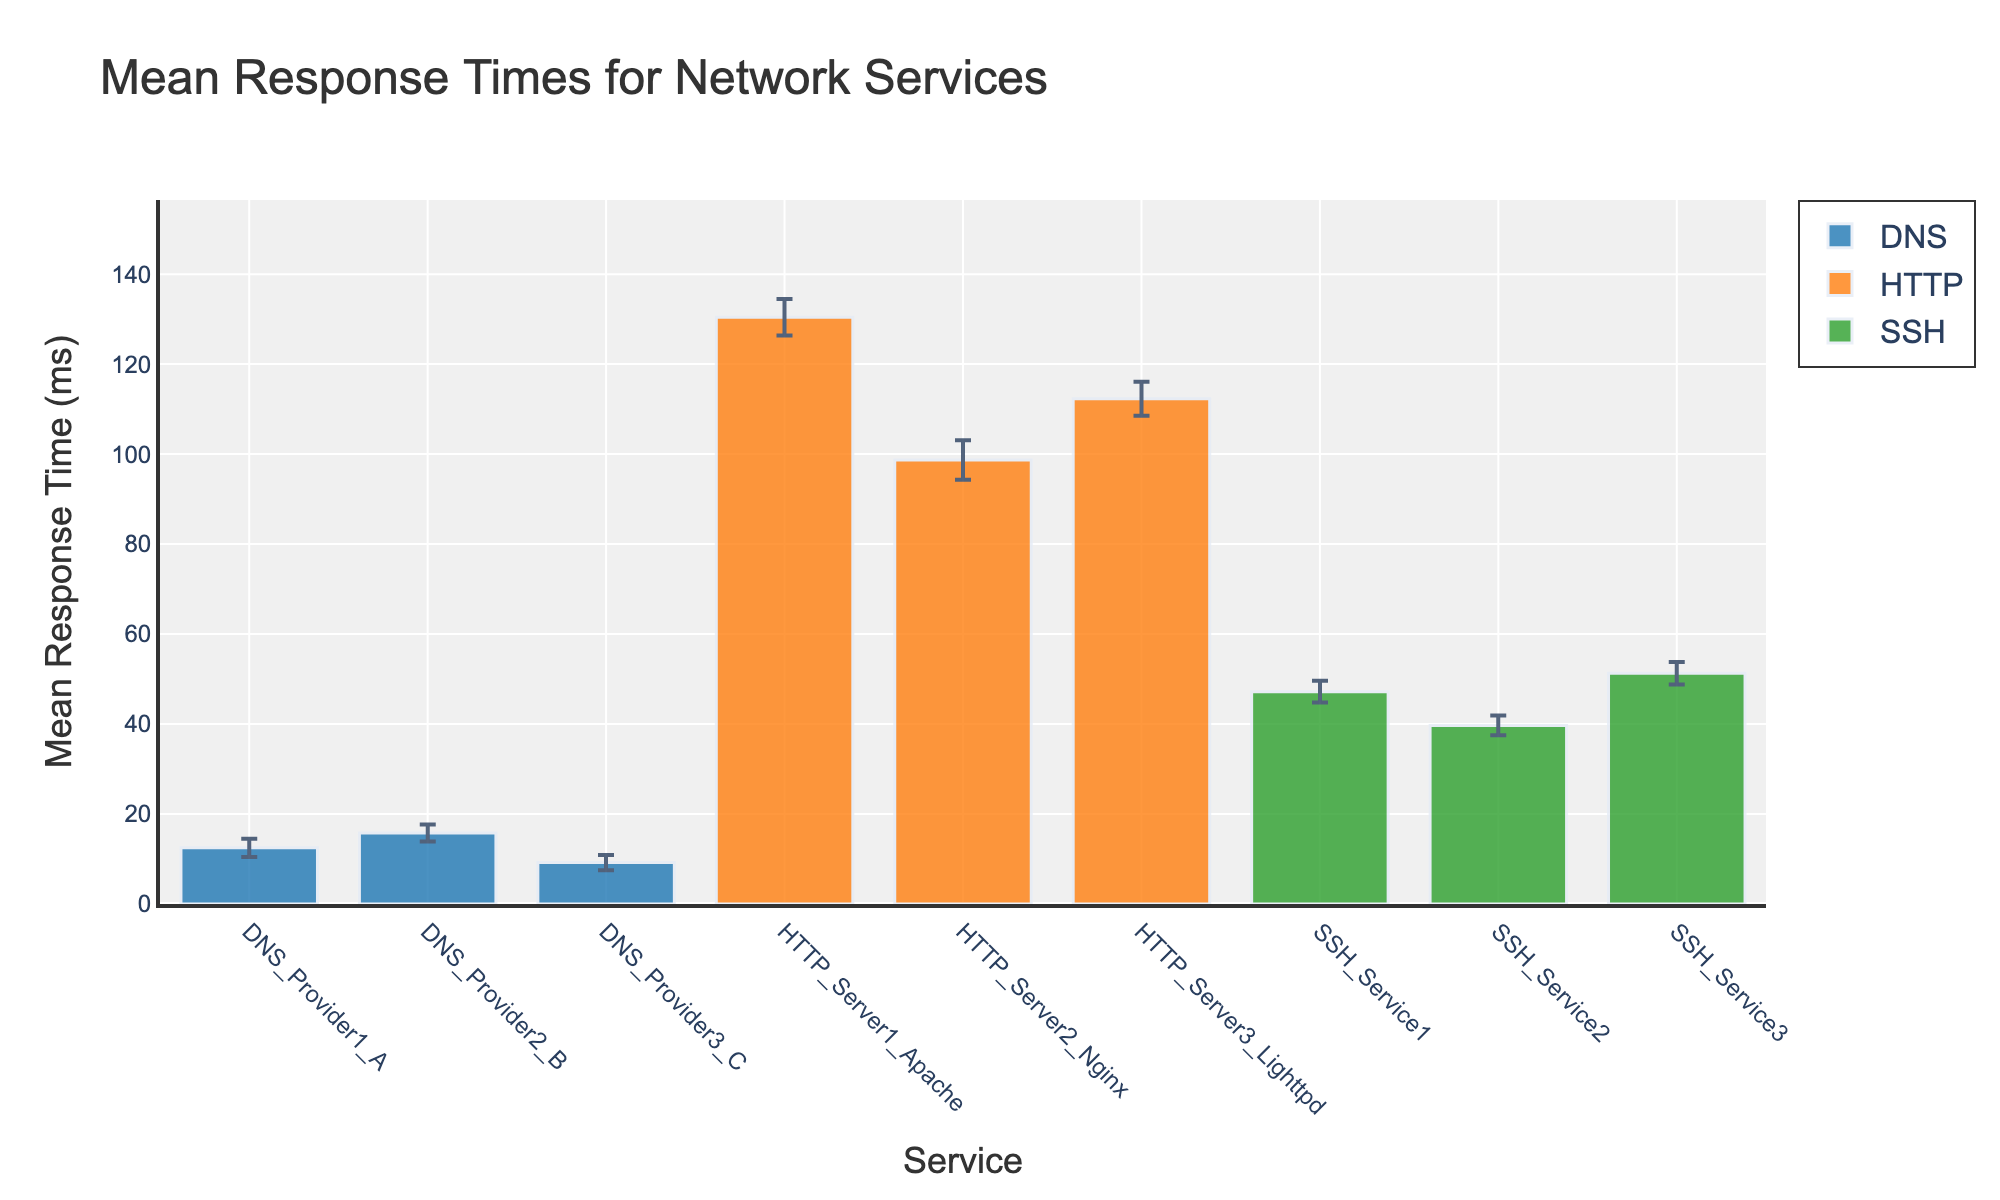What's the title of the figure? The title is located prominently at the top of the figure, which reads "Mean Response Times for Network Services".
Answer: Mean Response Times for Network Services What are the three types of services compared in the figure? The x-axis labels indicate the three types of services: DNS, HTTP, and SSH. Each group of bars corresponds to these service types.
Answer: DNS, HTTP, SSH Which service has the highest mean response time? From the y-axis, the highest bar indicates the service with the highest mean response time. In this case, it's "HTTP_Server1_Apache".
Answer: HTTP_Server1_Apache What is the mean response time for HTTP_Server2_Nginx? The height of the bar for HTTP_Server2_Nginx on the y-axis shows its mean response time, which is labeled as 98.7 ms.
Answer: 98.7 ms How does the mean response time of DNS_Provider1_A compare to that of DNS_Provider3_C? To compare, we look at the heights of the bars for DNS_Provider1_A and DNS_Provider3_C. DNS_Provider1_A has a higher mean response time than DNS_Provider3_C.
Answer: DNS_Provider1_A has a higher mean response time In which service type is the variance in response times the largest? Error bars indicate variability. HTTP services show larger error bars than DNS and SSH, with HTTP_Server2_Nginx having the largest error bar.
Answer: HTTP What is the range of mean response times for the SSH services? Identifying the highest and lowest bars in the SSH group gives us the range. SSH_Service3 is the highest at 51.3 ms and SSH_Service2 is the lowest at 39.7 ms. So, the range is 51.3 - 39.7 = 11.6 ms.
Answer: 11.6 ms Which DNS provider has the smallest variance in response times? The error bars for DNS providers indicate their variance, with DNS_Provider3_C showing the smallest variance based on the shortest error bar.
Answer: DNS_Provider3_C What is the difference in mean response times between the fastest and slowest HTTP services? Identifying the highest and lowest bars in the HTTP group: HTTP_Server1_Apache is the slowest at 130.4 ms, and HTTP_Server2_Nginx is the fastest at 98.7 ms. The difference is 130.4 - 98.7 = 31.7 ms.
Answer: 31.7 ms 